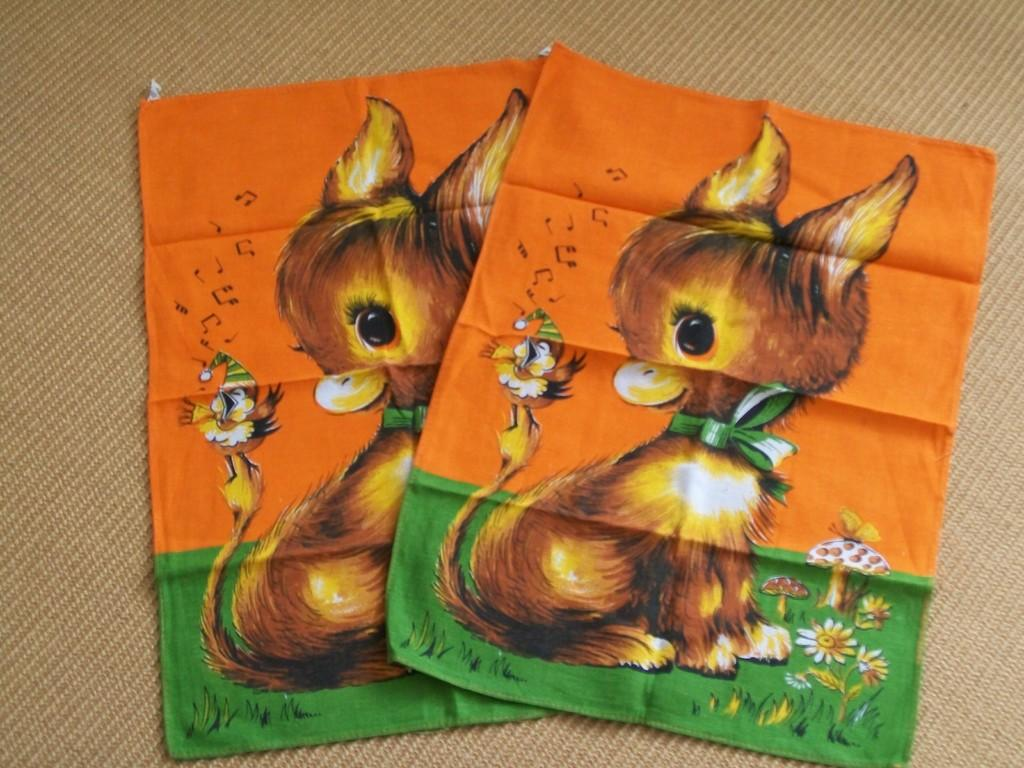What is the main subject of the image? The main subject of the image is a cloth. What types of images are present on the cloth? The cloth contains images of animals, birds, and mushrooms. What type of canvas is visible in the image? There is no canvas present in the image; it features a cloth with images of animals, birds, and mushrooms. How many mittens are present on the cloth in the image? There are no mittens present on the cloth in the image. 